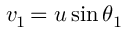<formula> <loc_0><loc_0><loc_500><loc_500>v _ { 1 \, } = u \sin \theta _ { 1 }</formula> 